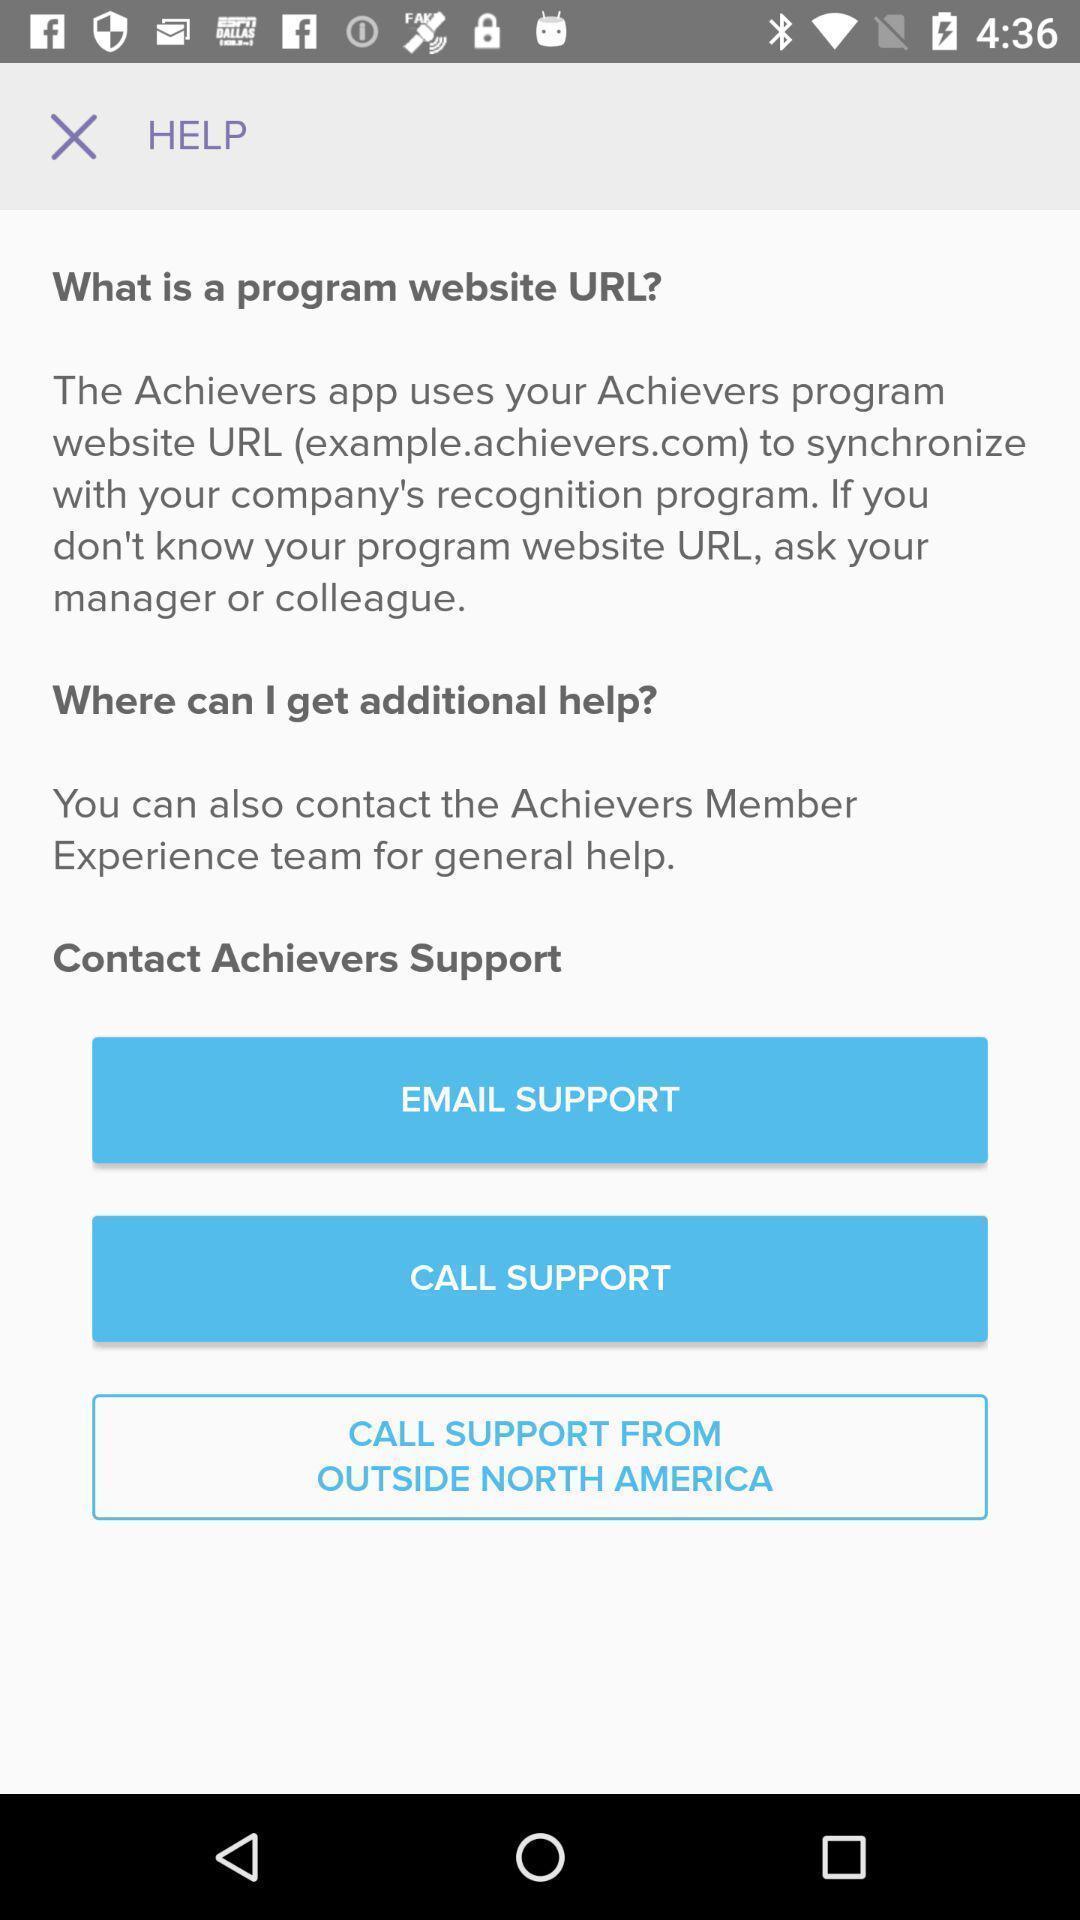Describe the content in this image. Screen shows help details. 